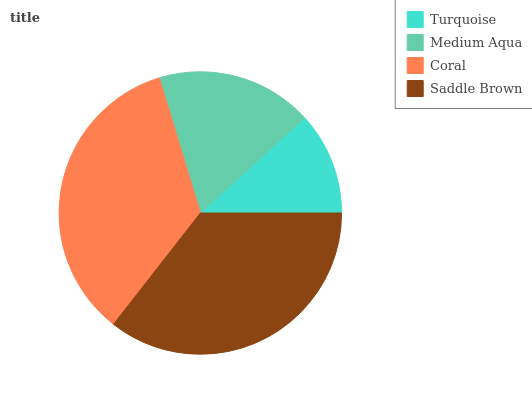Is Turquoise the minimum?
Answer yes or no. Yes. Is Saddle Brown the maximum?
Answer yes or no. Yes. Is Medium Aqua the minimum?
Answer yes or no. No. Is Medium Aqua the maximum?
Answer yes or no. No. Is Medium Aqua greater than Turquoise?
Answer yes or no. Yes. Is Turquoise less than Medium Aqua?
Answer yes or no. Yes. Is Turquoise greater than Medium Aqua?
Answer yes or no. No. Is Medium Aqua less than Turquoise?
Answer yes or no. No. Is Coral the high median?
Answer yes or no. Yes. Is Medium Aqua the low median?
Answer yes or no. Yes. Is Medium Aqua the high median?
Answer yes or no. No. Is Saddle Brown the low median?
Answer yes or no. No. 